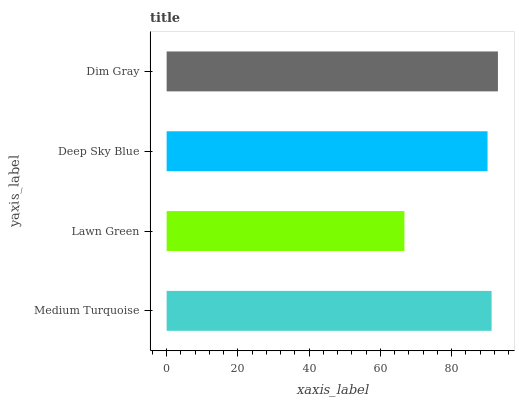Is Lawn Green the minimum?
Answer yes or no. Yes. Is Dim Gray the maximum?
Answer yes or no. Yes. Is Deep Sky Blue the minimum?
Answer yes or no. No. Is Deep Sky Blue the maximum?
Answer yes or no. No. Is Deep Sky Blue greater than Lawn Green?
Answer yes or no. Yes. Is Lawn Green less than Deep Sky Blue?
Answer yes or no. Yes. Is Lawn Green greater than Deep Sky Blue?
Answer yes or no. No. Is Deep Sky Blue less than Lawn Green?
Answer yes or no. No. Is Medium Turquoise the high median?
Answer yes or no. Yes. Is Deep Sky Blue the low median?
Answer yes or no. Yes. Is Dim Gray the high median?
Answer yes or no. No. Is Medium Turquoise the low median?
Answer yes or no. No. 